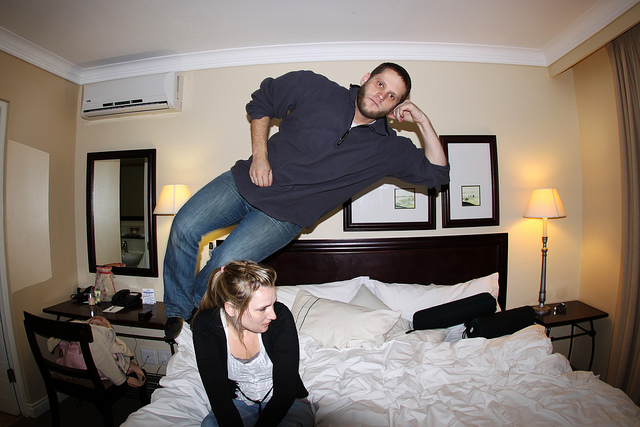How many people can be seen? 2 